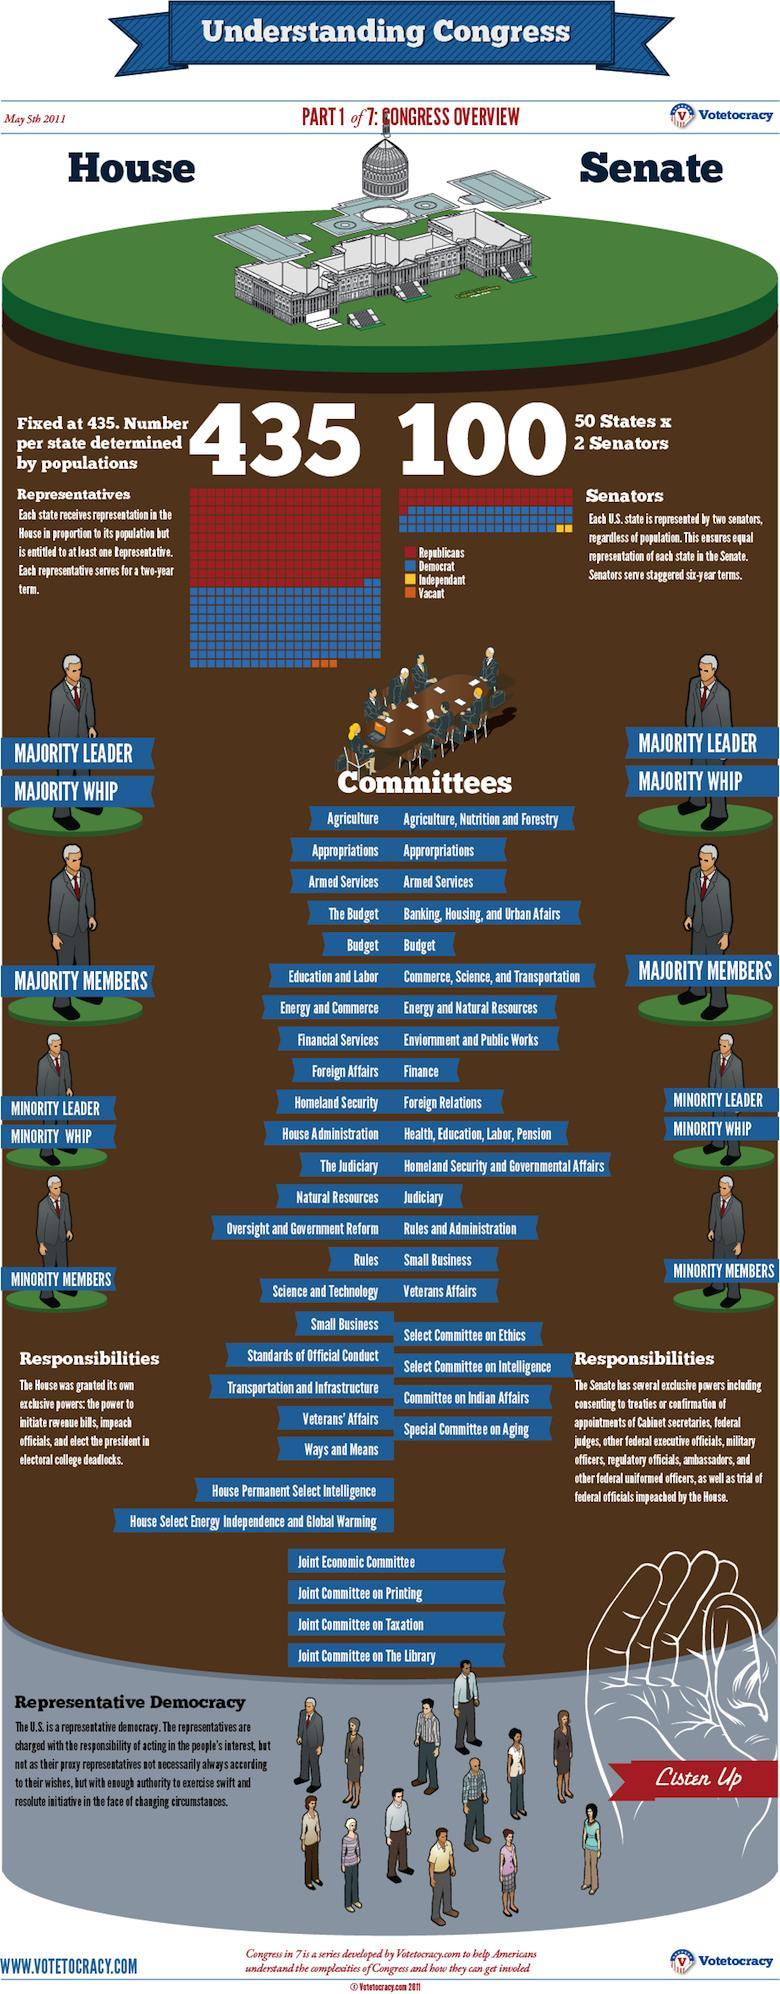How many blocks represent "vacant"?
Answer the question with a short phrase. 3 How many blocks represent "independent"? 2 Which color used to represent "democrat"-orange, blue, yellow, red? yellow 